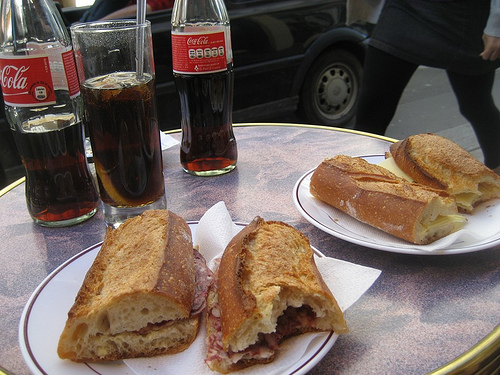Please transcribe the text in this image. CocaCola Cola 